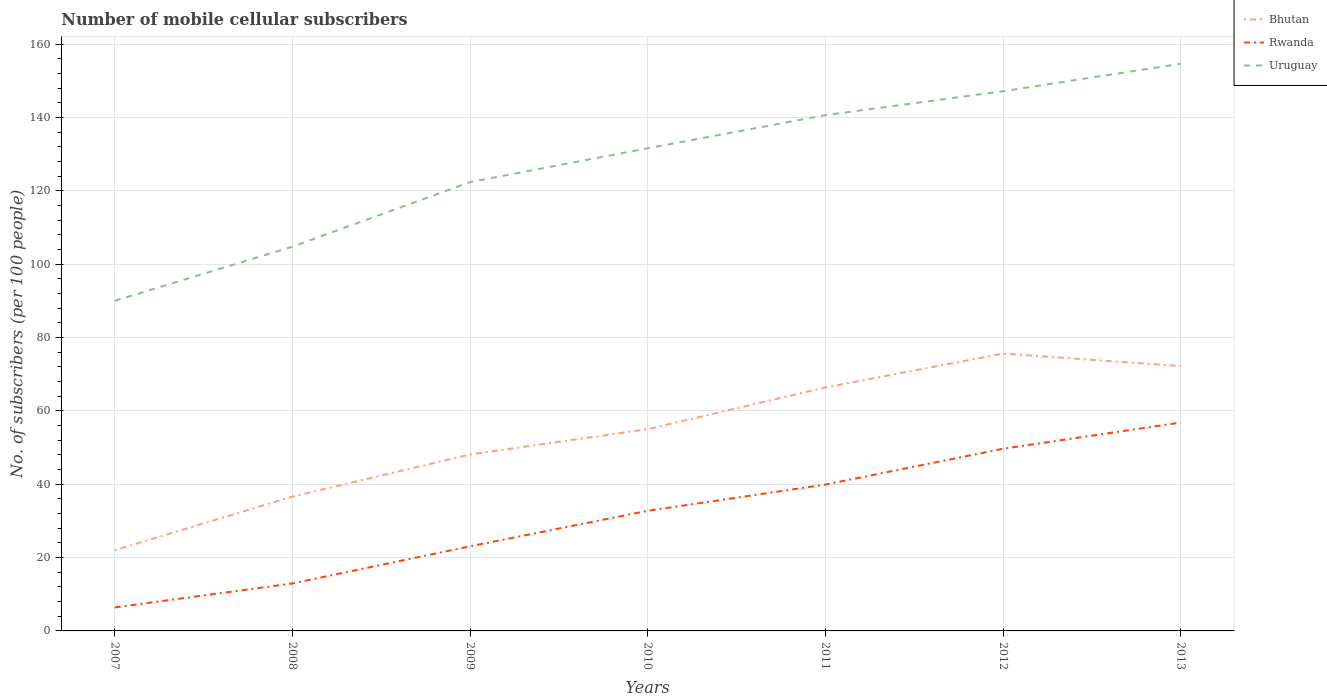Across all years, what is the maximum number of mobile cellular subscribers in Bhutan?
Keep it short and to the point. 22. In which year was the number of mobile cellular subscribers in Rwanda maximum?
Your answer should be very brief. 2007. What is the total number of mobile cellular subscribers in Rwanda in the graph?
Ensure brevity in your answer.  -7.13. What is the difference between the highest and the second highest number of mobile cellular subscribers in Rwanda?
Offer a terse response. 50.4. What is the difference between the highest and the lowest number of mobile cellular subscribers in Rwanda?
Make the answer very short. 4. Is the number of mobile cellular subscribers in Rwanda strictly greater than the number of mobile cellular subscribers in Bhutan over the years?
Offer a very short reply. Yes. How many lines are there?
Give a very brief answer. 3. Does the graph contain any zero values?
Keep it short and to the point. No. Does the graph contain grids?
Your answer should be very brief. Yes. What is the title of the graph?
Your response must be concise. Number of mobile cellular subscribers. What is the label or title of the Y-axis?
Your answer should be very brief. No. of subscribers (per 100 people). What is the No. of subscribers (per 100 people) of Bhutan in 2007?
Offer a very short reply. 22. What is the No. of subscribers (per 100 people) of Rwanda in 2007?
Provide a short and direct response. 6.4. What is the No. of subscribers (per 100 people) in Uruguay in 2007?
Keep it short and to the point. 89.99. What is the No. of subscribers (per 100 people) of Bhutan in 2008?
Provide a succinct answer. 36.61. What is the No. of subscribers (per 100 people) of Rwanda in 2008?
Provide a short and direct response. 12.94. What is the No. of subscribers (per 100 people) of Uruguay in 2008?
Your answer should be compact. 104.75. What is the No. of subscribers (per 100 people) of Bhutan in 2009?
Provide a succinct answer. 48.11. What is the No. of subscribers (per 100 people) of Rwanda in 2009?
Keep it short and to the point. 23.07. What is the No. of subscribers (per 100 people) in Uruguay in 2009?
Keep it short and to the point. 122.35. What is the No. of subscribers (per 100 people) in Bhutan in 2010?
Offer a very short reply. 55. What is the No. of subscribers (per 100 people) of Rwanda in 2010?
Ensure brevity in your answer.  32.75. What is the No. of subscribers (per 100 people) of Uruguay in 2010?
Your response must be concise. 131.59. What is the No. of subscribers (per 100 people) in Bhutan in 2011?
Ensure brevity in your answer.  66.38. What is the No. of subscribers (per 100 people) in Rwanda in 2011?
Your answer should be compact. 39.9. What is the No. of subscribers (per 100 people) in Uruguay in 2011?
Your answer should be very brief. 140.61. What is the No. of subscribers (per 100 people) in Bhutan in 2012?
Make the answer very short. 75.61. What is the No. of subscribers (per 100 people) of Rwanda in 2012?
Offer a terse response. 49.67. What is the No. of subscribers (per 100 people) in Uruguay in 2012?
Provide a short and direct response. 147.13. What is the No. of subscribers (per 100 people) of Bhutan in 2013?
Offer a terse response. 72.2. What is the No. of subscribers (per 100 people) of Rwanda in 2013?
Provide a short and direct response. 56.8. What is the No. of subscribers (per 100 people) of Uruguay in 2013?
Give a very brief answer. 154.62. Across all years, what is the maximum No. of subscribers (per 100 people) of Bhutan?
Provide a succinct answer. 75.61. Across all years, what is the maximum No. of subscribers (per 100 people) of Rwanda?
Offer a very short reply. 56.8. Across all years, what is the maximum No. of subscribers (per 100 people) in Uruguay?
Your answer should be compact. 154.62. Across all years, what is the minimum No. of subscribers (per 100 people) in Bhutan?
Keep it short and to the point. 22. Across all years, what is the minimum No. of subscribers (per 100 people) of Rwanda?
Offer a terse response. 6.4. Across all years, what is the minimum No. of subscribers (per 100 people) in Uruguay?
Ensure brevity in your answer.  89.99. What is the total No. of subscribers (per 100 people) of Bhutan in the graph?
Your answer should be compact. 375.91. What is the total No. of subscribers (per 100 people) of Rwanda in the graph?
Provide a short and direct response. 221.52. What is the total No. of subscribers (per 100 people) of Uruguay in the graph?
Your answer should be compact. 891.04. What is the difference between the No. of subscribers (per 100 people) in Bhutan in 2007 and that in 2008?
Ensure brevity in your answer.  -14.62. What is the difference between the No. of subscribers (per 100 people) in Rwanda in 2007 and that in 2008?
Your answer should be compact. -6.54. What is the difference between the No. of subscribers (per 100 people) of Uruguay in 2007 and that in 2008?
Offer a very short reply. -14.75. What is the difference between the No. of subscribers (per 100 people) in Bhutan in 2007 and that in 2009?
Your answer should be very brief. -26.11. What is the difference between the No. of subscribers (per 100 people) in Rwanda in 2007 and that in 2009?
Ensure brevity in your answer.  -16.67. What is the difference between the No. of subscribers (per 100 people) of Uruguay in 2007 and that in 2009?
Your answer should be compact. -32.36. What is the difference between the No. of subscribers (per 100 people) of Bhutan in 2007 and that in 2010?
Offer a terse response. -33. What is the difference between the No. of subscribers (per 100 people) in Rwanda in 2007 and that in 2010?
Offer a terse response. -26.35. What is the difference between the No. of subscribers (per 100 people) of Uruguay in 2007 and that in 2010?
Ensure brevity in your answer.  -41.6. What is the difference between the No. of subscribers (per 100 people) in Bhutan in 2007 and that in 2011?
Offer a terse response. -44.38. What is the difference between the No. of subscribers (per 100 people) of Rwanda in 2007 and that in 2011?
Your response must be concise. -33.5. What is the difference between the No. of subscribers (per 100 people) in Uruguay in 2007 and that in 2011?
Your answer should be very brief. -50.61. What is the difference between the No. of subscribers (per 100 people) in Bhutan in 2007 and that in 2012?
Keep it short and to the point. -53.61. What is the difference between the No. of subscribers (per 100 people) in Rwanda in 2007 and that in 2012?
Offer a terse response. -43.27. What is the difference between the No. of subscribers (per 100 people) of Uruguay in 2007 and that in 2012?
Give a very brief answer. -57.14. What is the difference between the No. of subscribers (per 100 people) in Bhutan in 2007 and that in 2013?
Your answer should be compact. -50.2. What is the difference between the No. of subscribers (per 100 people) of Rwanda in 2007 and that in 2013?
Give a very brief answer. -50.4. What is the difference between the No. of subscribers (per 100 people) of Uruguay in 2007 and that in 2013?
Give a very brief answer. -64.63. What is the difference between the No. of subscribers (per 100 people) of Bhutan in 2008 and that in 2009?
Offer a very short reply. -11.49. What is the difference between the No. of subscribers (per 100 people) in Rwanda in 2008 and that in 2009?
Your answer should be compact. -10.13. What is the difference between the No. of subscribers (per 100 people) of Uruguay in 2008 and that in 2009?
Provide a short and direct response. -17.61. What is the difference between the No. of subscribers (per 100 people) in Bhutan in 2008 and that in 2010?
Give a very brief answer. -18.39. What is the difference between the No. of subscribers (per 100 people) in Rwanda in 2008 and that in 2010?
Offer a very short reply. -19.81. What is the difference between the No. of subscribers (per 100 people) in Uruguay in 2008 and that in 2010?
Offer a very short reply. -26.84. What is the difference between the No. of subscribers (per 100 people) of Bhutan in 2008 and that in 2011?
Your response must be concise. -29.76. What is the difference between the No. of subscribers (per 100 people) of Rwanda in 2008 and that in 2011?
Your answer should be compact. -26.96. What is the difference between the No. of subscribers (per 100 people) of Uruguay in 2008 and that in 2011?
Provide a short and direct response. -35.86. What is the difference between the No. of subscribers (per 100 people) of Bhutan in 2008 and that in 2012?
Keep it short and to the point. -39. What is the difference between the No. of subscribers (per 100 people) of Rwanda in 2008 and that in 2012?
Offer a terse response. -36.73. What is the difference between the No. of subscribers (per 100 people) of Uruguay in 2008 and that in 2012?
Give a very brief answer. -42.39. What is the difference between the No. of subscribers (per 100 people) in Bhutan in 2008 and that in 2013?
Provide a short and direct response. -35.58. What is the difference between the No. of subscribers (per 100 people) of Rwanda in 2008 and that in 2013?
Offer a very short reply. -43.86. What is the difference between the No. of subscribers (per 100 people) in Uruguay in 2008 and that in 2013?
Provide a succinct answer. -49.87. What is the difference between the No. of subscribers (per 100 people) in Bhutan in 2009 and that in 2010?
Offer a very short reply. -6.89. What is the difference between the No. of subscribers (per 100 people) in Rwanda in 2009 and that in 2010?
Your answer should be compact. -9.68. What is the difference between the No. of subscribers (per 100 people) of Uruguay in 2009 and that in 2010?
Your answer should be compact. -9.24. What is the difference between the No. of subscribers (per 100 people) of Bhutan in 2009 and that in 2011?
Your answer should be very brief. -18.27. What is the difference between the No. of subscribers (per 100 people) in Rwanda in 2009 and that in 2011?
Provide a short and direct response. -16.83. What is the difference between the No. of subscribers (per 100 people) in Uruguay in 2009 and that in 2011?
Your response must be concise. -18.25. What is the difference between the No. of subscribers (per 100 people) in Bhutan in 2009 and that in 2012?
Provide a succinct answer. -27.5. What is the difference between the No. of subscribers (per 100 people) in Rwanda in 2009 and that in 2012?
Offer a very short reply. -26.6. What is the difference between the No. of subscribers (per 100 people) in Uruguay in 2009 and that in 2012?
Your answer should be very brief. -24.78. What is the difference between the No. of subscribers (per 100 people) of Bhutan in 2009 and that in 2013?
Ensure brevity in your answer.  -24.09. What is the difference between the No. of subscribers (per 100 people) of Rwanda in 2009 and that in 2013?
Give a very brief answer. -33.73. What is the difference between the No. of subscribers (per 100 people) in Uruguay in 2009 and that in 2013?
Give a very brief answer. -32.27. What is the difference between the No. of subscribers (per 100 people) in Bhutan in 2010 and that in 2011?
Offer a very short reply. -11.38. What is the difference between the No. of subscribers (per 100 people) of Rwanda in 2010 and that in 2011?
Ensure brevity in your answer.  -7.15. What is the difference between the No. of subscribers (per 100 people) in Uruguay in 2010 and that in 2011?
Offer a very short reply. -9.02. What is the difference between the No. of subscribers (per 100 people) of Bhutan in 2010 and that in 2012?
Provide a short and direct response. -20.61. What is the difference between the No. of subscribers (per 100 people) in Rwanda in 2010 and that in 2012?
Your response must be concise. -16.92. What is the difference between the No. of subscribers (per 100 people) in Uruguay in 2010 and that in 2012?
Your answer should be very brief. -15.54. What is the difference between the No. of subscribers (per 100 people) of Bhutan in 2010 and that in 2013?
Provide a short and direct response. -17.2. What is the difference between the No. of subscribers (per 100 people) in Rwanda in 2010 and that in 2013?
Ensure brevity in your answer.  -24.05. What is the difference between the No. of subscribers (per 100 people) of Uruguay in 2010 and that in 2013?
Keep it short and to the point. -23.03. What is the difference between the No. of subscribers (per 100 people) in Bhutan in 2011 and that in 2012?
Your answer should be compact. -9.23. What is the difference between the No. of subscribers (per 100 people) in Rwanda in 2011 and that in 2012?
Make the answer very short. -9.77. What is the difference between the No. of subscribers (per 100 people) of Uruguay in 2011 and that in 2012?
Give a very brief answer. -6.52. What is the difference between the No. of subscribers (per 100 people) of Bhutan in 2011 and that in 2013?
Offer a terse response. -5.82. What is the difference between the No. of subscribers (per 100 people) in Rwanda in 2011 and that in 2013?
Your answer should be compact. -16.9. What is the difference between the No. of subscribers (per 100 people) of Uruguay in 2011 and that in 2013?
Ensure brevity in your answer.  -14.01. What is the difference between the No. of subscribers (per 100 people) in Bhutan in 2012 and that in 2013?
Your response must be concise. 3.41. What is the difference between the No. of subscribers (per 100 people) of Rwanda in 2012 and that in 2013?
Keep it short and to the point. -7.13. What is the difference between the No. of subscribers (per 100 people) of Uruguay in 2012 and that in 2013?
Your response must be concise. -7.49. What is the difference between the No. of subscribers (per 100 people) in Bhutan in 2007 and the No. of subscribers (per 100 people) in Rwanda in 2008?
Provide a short and direct response. 9.06. What is the difference between the No. of subscribers (per 100 people) in Bhutan in 2007 and the No. of subscribers (per 100 people) in Uruguay in 2008?
Offer a very short reply. -82.75. What is the difference between the No. of subscribers (per 100 people) of Rwanda in 2007 and the No. of subscribers (per 100 people) of Uruguay in 2008?
Offer a very short reply. -98.35. What is the difference between the No. of subscribers (per 100 people) in Bhutan in 2007 and the No. of subscribers (per 100 people) in Rwanda in 2009?
Give a very brief answer. -1.07. What is the difference between the No. of subscribers (per 100 people) in Bhutan in 2007 and the No. of subscribers (per 100 people) in Uruguay in 2009?
Offer a very short reply. -100.36. What is the difference between the No. of subscribers (per 100 people) of Rwanda in 2007 and the No. of subscribers (per 100 people) of Uruguay in 2009?
Your response must be concise. -115.95. What is the difference between the No. of subscribers (per 100 people) of Bhutan in 2007 and the No. of subscribers (per 100 people) of Rwanda in 2010?
Offer a very short reply. -10.75. What is the difference between the No. of subscribers (per 100 people) of Bhutan in 2007 and the No. of subscribers (per 100 people) of Uruguay in 2010?
Offer a very short reply. -109.59. What is the difference between the No. of subscribers (per 100 people) of Rwanda in 2007 and the No. of subscribers (per 100 people) of Uruguay in 2010?
Keep it short and to the point. -125.19. What is the difference between the No. of subscribers (per 100 people) in Bhutan in 2007 and the No. of subscribers (per 100 people) in Rwanda in 2011?
Give a very brief answer. -17.9. What is the difference between the No. of subscribers (per 100 people) of Bhutan in 2007 and the No. of subscribers (per 100 people) of Uruguay in 2011?
Give a very brief answer. -118.61. What is the difference between the No. of subscribers (per 100 people) of Rwanda in 2007 and the No. of subscribers (per 100 people) of Uruguay in 2011?
Make the answer very short. -134.21. What is the difference between the No. of subscribers (per 100 people) of Bhutan in 2007 and the No. of subscribers (per 100 people) of Rwanda in 2012?
Offer a very short reply. -27.67. What is the difference between the No. of subscribers (per 100 people) in Bhutan in 2007 and the No. of subscribers (per 100 people) in Uruguay in 2012?
Keep it short and to the point. -125.13. What is the difference between the No. of subscribers (per 100 people) in Rwanda in 2007 and the No. of subscribers (per 100 people) in Uruguay in 2012?
Offer a terse response. -140.73. What is the difference between the No. of subscribers (per 100 people) in Bhutan in 2007 and the No. of subscribers (per 100 people) in Rwanda in 2013?
Provide a short and direct response. -34.8. What is the difference between the No. of subscribers (per 100 people) of Bhutan in 2007 and the No. of subscribers (per 100 people) of Uruguay in 2013?
Offer a terse response. -132.62. What is the difference between the No. of subscribers (per 100 people) of Rwanda in 2007 and the No. of subscribers (per 100 people) of Uruguay in 2013?
Provide a succinct answer. -148.22. What is the difference between the No. of subscribers (per 100 people) in Bhutan in 2008 and the No. of subscribers (per 100 people) in Rwanda in 2009?
Provide a short and direct response. 13.54. What is the difference between the No. of subscribers (per 100 people) of Bhutan in 2008 and the No. of subscribers (per 100 people) of Uruguay in 2009?
Make the answer very short. -85.74. What is the difference between the No. of subscribers (per 100 people) in Rwanda in 2008 and the No. of subscribers (per 100 people) in Uruguay in 2009?
Keep it short and to the point. -109.41. What is the difference between the No. of subscribers (per 100 people) in Bhutan in 2008 and the No. of subscribers (per 100 people) in Rwanda in 2010?
Give a very brief answer. 3.87. What is the difference between the No. of subscribers (per 100 people) of Bhutan in 2008 and the No. of subscribers (per 100 people) of Uruguay in 2010?
Your answer should be very brief. -94.97. What is the difference between the No. of subscribers (per 100 people) in Rwanda in 2008 and the No. of subscribers (per 100 people) in Uruguay in 2010?
Make the answer very short. -118.65. What is the difference between the No. of subscribers (per 100 people) of Bhutan in 2008 and the No. of subscribers (per 100 people) of Rwanda in 2011?
Give a very brief answer. -3.28. What is the difference between the No. of subscribers (per 100 people) in Bhutan in 2008 and the No. of subscribers (per 100 people) in Uruguay in 2011?
Provide a succinct answer. -103.99. What is the difference between the No. of subscribers (per 100 people) of Rwanda in 2008 and the No. of subscribers (per 100 people) of Uruguay in 2011?
Give a very brief answer. -127.67. What is the difference between the No. of subscribers (per 100 people) of Bhutan in 2008 and the No. of subscribers (per 100 people) of Rwanda in 2012?
Keep it short and to the point. -13.05. What is the difference between the No. of subscribers (per 100 people) of Bhutan in 2008 and the No. of subscribers (per 100 people) of Uruguay in 2012?
Provide a short and direct response. -110.52. What is the difference between the No. of subscribers (per 100 people) of Rwanda in 2008 and the No. of subscribers (per 100 people) of Uruguay in 2012?
Make the answer very short. -134.19. What is the difference between the No. of subscribers (per 100 people) of Bhutan in 2008 and the No. of subscribers (per 100 people) of Rwanda in 2013?
Your answer should be compact. -20.19. What is the difference between the No. of subscribers (per 100 people) in Bhutan in 2008 and the No. of subscribers (per 100 people) in Uruguay in 2013?
Your answer should be very brief. -118. What is the difference between the No. of subscribers (per 100 people) in Rwanda in 2008 and the No. of subscribers (per 100 people) in Uruguay in 2013?
Your answer should be compact. -141.68. What is the difference between the No. of subscribers (per 100 people) of Bhutan in 2009 and the No. of subscribers (per 100 people) of Rwanda in 2010?
Your answer should be compact. 15.36. What is the difference between the No. of subscribers (per 100 people) of Bhutan in 2009 and the No. of subscribers (per 100 people) of Uruguay in 2010?
Your answer should be very brief. -83.48. What is the difference between the No. of subscribers (per 100 people) of Rwanda in 2009 and the No. of subscribers (per 100 people) of Uruguay in 2010?
Your answer should be very brief. -108.52. What is the difference between the No. of subscribers (per 100 people) of Bhutan in 2009 and the No. of subscribers (per 100 people) of Rwanda in 2011?
Your response must be concise. 8.21. What is the difference between the No. of subscribers (per 100 people) of Bhutan in 2009 and the No. of subscribers (per 100 people) of Uruguay in 2011?
Your answer should be compact. -92.5. What is the difference between the No. of subscribers (per 100 people) of Rwanda in 2009 and the No. of subscribers (per 100 people) of Uruguay in 2011?
Ensure brevity in your answer.  -117.54. What is the difference between the No. of subscribers (per 100 people) in Bhutan in 2009 and the No. of subscribers (per 100 people) in Rwanda in 2012?
Your answer should be compact. -1.56. What is the difference between the No. of subscribers (per 100 people) in Bhutan in 2009 and the No. of subscribers (per 100 people) in Uruguay in 2012?
Give a very brief answer. -99.02. What is the difference between the No. of subscribers (per 100 people) in Rwanda in 2009 and the No. of subscribers (per 100 people) in Uruguay in 2012?
Offer a terse response. -124.06. What is the difference between the No. of subscribers (per 100 people) of Bhutan in 2009 and the No. of subscribers (per 100 people) of Rwanda in 2013?
Your answer should be very brief. -8.69. What is the difference between the No. of subscribers (per 100 people) in Bhutan in 2009 and the No. of subscribers (per 100 people) in Uruguay in 2013?
Provide a short and direct response. -106.51. What is the difference between the No. of subscribers (per 100 people) of Rwanda in 2009 and the No. of subscribers (per 100 people) of Uruguay in 2013?
Your answer should be compact. -131.55. What is the difference between the No. of subscribers (per 100 people) in Bhutan in 2010 and the No. of subscribers (per 100 people) in Rwanda in 2011?
Your response must be concise. 15.1. What is the difference between the No. of subscribers (per 100 people) in Bhutan in 2010 and the No. of subscribers (per 100 people) in Uruguay in 2011?
Offer a very short reply. -85.61. What is the difference between the No. of subscribers (per 100 people) in Rwanda in 2010 and the No. of subscribers (per 100 people) in Uruguay in 2011?
Keep it short and to the point. -107.86. What is the difference between the No. of subscribers (per 100 people) of Bhutan in 2010 and the No. of subscribers (per 100 people) of Rwanda in 2012?
Provide a succinct answer. 5.33. What is the difference between the No. of subscribers (per 100 people) in Bhutan in 2010 and the No. of subscribers (per 100 people) in Uruguay in 2012?
Your response must be concise. -92.13. What is the difference between the No. of subscribers (per 100 people) in Rwanda in 2010 and the No. of subscribers (per 100 people) in Uruguay in 2012?
Offer a terse response. -114.38. What is the difference between the No. of subscribers (per 100 people) in Bhutan in 2010 and the No. of subscribers (per 100 people) in Rwanda in 2013?
Offer a very short reply. -1.8. What is the difference between the No. of subscribers (per 100 people) of Bhutan in 2010 and the No. of subscribers (per 100 people) of Uruguay in 2013?
Provide a succinct answer. -99.62. What is the difference between the No. of subscribers (per 100 people) of Rwanda in 2010 and the No. of subscribers (per 100 people) of Uruguay in 2013?
Make the answer very short. -121.87. What is the difference between the No. of subscribers (per 100 people) of Bhutan in 2011 and the No. of subscribers (per 100 people) of Rwanda in 2012?
Ensure brevity in your answer.  16.71. What is the difference between the No. of subscribers (per 100 people) in Bhutan in 2011 and the No. of subscribers (per 100 people) in Uruguay in 2012?
Your answer should be very brief. -80.75. What is the difference between the No. of subscribers (per 100 people) of Rwanda in 2011 and the No. of subscribers (per 100 people) of Uruguay in 2012?
Offer a very short reply. -107.23. What is the difference between the No. of subscribers (per 100 people) in Bhutan in 2011 and the No. of subscribers (per 100 people) in Rwanda in 2013?
Your response must be concise. 9.58. What is the difference between the No. of subscribers (per 100 people) of Bhutan in 2011 and the No. of subscribers (per 100 people) of Uruguay in 2013?
Give a very brief answer. -88.24. What is the difference between the No. of subscribers (per 100 people) in Rwanda in 2011 and the No. of subscribers (per 100 people) in Uruguay in 2013?
Provide a short and direct response. -114.72. What is the difference between the No. of subscribers (per 100 people) in Bhutan in 2012 and the No. of subscribers (per 100 people) in Rwanda in 2013?
Provide a succinct answer. 18.81. What is the difference between the No. of subscribers (per 100 people) of Bhutan in 2012 and the No. of subscribers (per 100 people) of Uruguay in 2013?
Your response must be concise. -79.01. What is the difference between the No. of subscribers (per 100 people) in Rwanda in 2012 and the No. of subscribers (per 100 people) in Uruguay in 2013?
Provide a succinct answer. -104.95. What is the average No. of subscribers (per 100 people) in Bhutan per year?
Offer a terse response. 53.7. What is the average No. of subscribers (per 100 people) in Rwanda per year?
Ensure brevity in your answer.  31.65. What is the average No. of subscribers (per 100 people) of Uruguay per year?
Ensure brevity in your answer.  127.29. In the year 2007, what is the difference between the No. of subscribers (per 100 people) of Bhutan and No. of subscribers (per 100 people) of Rwanda?
Give a very brief answer. 15.6. In the year 2007, what is the difference between the No. of subscribers (per 100 people) in Bhutan and No. of subscribers (per 100 people) in Uruguay?
Offer a very short reply. -68. In the year 2007, what is the difference between the No. of subscribers (per 100 people) of Rwanda and No. of subscribers (per 100 people) of Uruguay?
Your answer should be very brief. -83.6. In the year 2008, what is the difference between the No. of subscribers (per 100 people) in Bhutan and No. of subscribers (per 100 people) in Rwanda?
Your response must be concise. 23.68. In the year 2008, what is the difference between the No. of subscribers (per 100 people) of Bhutan and No. of subscribers (per 100 people) of Uruguay?
Provide a succinct answer. -68.13. In the year 2008, what is the difference between the No. of subscribers (per 100 people) in Rwanda and No. of subscribers (per 100 people) in Uruguay?
Provide a short and direct response. -91.81. In the year 2009, what is the difference between the No. of subscribers (per 100 people) in Bhutan and No. of subscribers (per 100 people) in Rwanda?
Provide a succinct answer. 25.04. In the year 2009, what is the difference between the No. of subscribers (per 100 people) in Bhutan and No. of subscribers (per 100 people) in Uruguay?
Provide a succinct answer. -74.24. In the year 2009, what is the difference between the No. of subscribers (per 100 people) of Rwanda and No. of subscribers (per 100 people) of Uruguay?
Give a very brief answer. -99.28. In the year 2010, what is the difference between the No. of subscribers (per 100 people) in Bhutan and No. of subscribers (per 100 people) in Rwanda?
Offer a very short reply. 22.25. In the year 2010, what is the difference between the No. of subscribers (per 100 people) of Bhutan and No. of subscribers (per 100 people) of Uruguay?
Make the answer very short. -76.59. In the year 2010, what is the difference between the No. of subscribers (per 100 people) of Rwanda and No. of subscribers (per 100 people) of Uruguay?
Offer a terse response. -98.84. In the year 2011, what is the difference between the No. of subscribers (per 100 people) of Bhutan and No. of subscribers (per 100 people) of Rwanda?
Offer a terse response. 26.48. In the year 2011, what is the difference between the No. of subscribers (per 100 people) in Bhutan and No. of subscribers (per 100 people) in Uruguay?
Your answer should be very brief. -74.23. In the year 2011, what is the difference between the No. of subscribers (per 100 people) of Rwanda and No. of subscribers (per 100 people) of Uruguay?
Ensure brevity in your answer.  -100.71. In the year 2012, what is the difference between the No. of subscribers (per 100 people) in Bhutan and No. of subscribers (per 100 people) in Rwanda?
Your answer should be very brief. 25.94. In the year 2012, what is the difference between the No. of subscribers (per 100 people) in Bhutan and No. of subscribers (per 100 people) in Uruguay?
Give a very brief answer. -71.52. In the year 2012, what is the difference between the No. of subscribers (per 100 people) of Rwanda and No. of subscribers (per 100 people) of Uruguay?
Provide a succinct answer. -97.46. In the year 2013, what is the difference between the No. of subscribers (per 100 people) in Bhutan and No. of subscribers (per 100 people) in Rwanda?
Offer a terse response. 15.4. In the year 2013, what is the difference between the No. of subscribers (per 100 people) of Bhutan and No. of subscribers (per 100 people) of Uruguay?
Ensure brevity in your answer.  -82.42. In the year 2013, what is the difference between the No. of subscribers (per 100 people) in Rwanda and No. of subscribers (per 100 people) in Uruguay?
Offer a very short reply. -97.82. What is the ratio of the No. of subscribers (per 100 people) of Bhutan in 2007 to that in 2008?
Give a very brief answer. 0.6. What is the ratio of the No. of subscribers (per 100 people) in Rwanda in 2007 to that in 2008?
Your answer should be very brief. 0.49. What is the ratio of the No. of subscribers (per 100 people) in Uruguay in 2007 to that in 2008?
Provide a short and direct response. 0.86. What is the ratio of the No. of subscribers (per 100 people) in Bhutan in 2007 to that in 2009?
Make the answer very short. 0.46. What is the ratio of the No. of subscribers (per 100 people) of Rwanda in 2007 to that in 2009?
Offer a terse response. 0.28. What is the ratio of the No. of subscribers (per 100 people) in Uruguay in 2007 to that in 2009?
Make the answer very short. 0.74. What is the ratio of the No. of subscribers (per 100 people) in Bhutan in 2007 to that in 2010?
Your answer should be compact. 0.4. What is the ratio of the No. of subscribers (per 100 people) in Rwanda in 2007 to that in 2010?
Provide a short and direct response. 0.2. What is the ratio of the No. of subscribers (per 100 people) in Uruguay in 2007 to that in 2010?
Provide a short and direct response. 0.68. What is the ratio of the No. of subscribers (per 100 people) in Bhutan in 2007 to that in 2011?
Ensure brevity in your answer.  0.33. What is the ratio of the No. of subscribers (per 100 people) in Rwanda in 2007 to that in 2011?
Provide a succinct answer. 0.16. What is the ratio of the No. of subscribers (per 100 people) of Uruguay in 2007 to that in 2011?
Make the answer very short. 0.64. What is the ratio of the No. of subscribers (per 100 people) of Bhutan in 2007 to that in 2012?
Provide a short and direct response. 0.29. What is the ratio of the No. of subscribers (per 100 people) of Rwanda in 2007 to that in 2012?
Offer a very short reply. 0.13. What is the ratio of the No. of subscribers (per 100 people) in Uruguay in 2007 to that in 2012?
Provide a short and direct response. 0.61. What is the ratio of the No. of subscribers (per 100 people) of Bhutan in 2007 to that in 2013?
Offer a very short reply. 0.3. What is the ratio of the No. of subscribers (per 100 people) in Rwanda in 2007 to that in 2013?
Make the answer very short. 0.11. What is the ratio of the No. of subscribers (per 100 people) in Uruguay in 2007 to that in 2013?
Provide a short and direct response. 0.58. What is the ratio of the No. of subscribers (per 100 people) in Bhutan in 2008 to that in 2009?
Make the answer very short. 0.76. What is the ratio of the No. of subscribers (per 100 people) in Rwanda in 2008 to that in 2009?
Provide a succinct answer. 0.56. What is the ratio of the No. of subscribers (per 100 people) in Uruguay in 2008 to that in 2009?
Your answer should be compact. 0.86. What is the ratio of the No. of subscribers (per 100 people) of Bhutan in 2008 to that in 2010?
Make the answer very short. 0.67. What is the ratio of the No. of subscribers (per 100 people) of Rwanda in 2008 to that in 2010?
Your answer should be very brief. 0.4. What is the ratio of the No. of subscribers (per 100 people) in Uruguay in 2008 to that in 2010?
Provide a succinct answer. 0.8. What is the ratio of the No. of subscribers (per 100 people) in Bhutan in 2008 to that in 2011?
Give a very brief answer. 0.55. What is the ratio of the No. of subscribers (per 100 people) in Rwanda in 2008 to that in 2011?
Make the answer very short. 0.32. What is the ratio of the No. of subscribers (per 100 people) in Uruguay in 2008 to that in 2011?
Offer a terse response. 0.74. What is the ratio of the No. of subscribers (per 100 people) of Bhutan in 2008 to that in 2012?
Your response must be concise. 0.48. What is the ratio of the No. of subscribers (per 100 people) in Rwanda in 2008 to that in 2012?
Provide a short and direct response. 0.26. What is the ratio of the No. of subscribers (per 100 people) of Uruguay in 2008 to that in 2012?
Make the answer very short. 0.71. What is the ratio of the No. of subscribers (per 100 people) of Bhutan in 2008 to that in 2013?
Your answer should be compact. 0.51. What is the ratio of the No. of subscribers (per 100 people) in Rwanda in 2008 to that in 2013?
Keep it short and to the point. 0.23. What is the ratio of the No. of subscribers (per 100 people) in Uruguay in 2008 to that in 2013?
Provide a succinct answer. 0.68. What is the ratio of the No. of subscribers (per 100 people) of Bhutan in 2009 to that in 2010?
Ensure brevity in your answer.  0.87. What is the ratio of the No. of subscribers (per 100 people) of Rwanda in 2009 to that in 2010?
Ensure brevity in your answer.  0.7. What is the ratio of the No. of subscribers (per 100 people) in Uruguay in 2009 to that in 2010?
Provide a succinct answer. 0.93. What is the ratio of the No. of subscribers (per 100 people) in Bhutan in 2009 to that in 2011?
Provide a succinct answer. 0.72. What is the ratio of the No. of subscribers (per 100 people) of Rwanda in 2009 to that in 2011?
Offer a terse response. 0.58. What is the ratio of the No. of subscribers (per 100 people) in Uruguay in 2009 to that in 2011?
Your answer should be compact. 0.87. What is the ratio of the No. of subscribers (per 100 people) in Bhutan in 2009 to that in 2012?
Your response must be concise. 0.64. What is the ratio of the No. of subscribers (per 100 people) in Rwanda in 2009 to that in 2012?
Provide a short and direct response. 0.46. What is the ratio of the No. of subscribers (per 100 people) in Uruguay in 2009 to that in 2012?
Your answer should be compact. 0.83. What is the ratio of the No. of subscribers (per 100 people) in Bhutan in 2009 to that in 2013?
Offer a very short reply. 0.67. What is the ratio of the No. of subscribers (per 100 people) in Rwanda in 2009 to that in 2013?
Provide a succinct answer. 0.41. What is the ratio of the No. of subscribers (per 100 people) in Uruguay in 2009 to that in 2013?
Your response must be concise. 0.79. What is the ratio of the No. of subscribers (per 100 people) in Bhutan in 2010 to that in 2011?
Your answer should be compact. 0.83. What is the ratio of the No. of subscribers (per 100 people) in Rwanda in 2010 to that in 2011?
Your answer should be very brief. 0.82. What is the ratio of the No. of subscribers (per 100 people) in Uruguay in 2010 to that in 2011?
Ensure brevity in your answer.  0.94. What is the ratio of the No. of subscribers (per 100 people) in Bhutan in 2010 to that in 2012?
Make the answer very short. 0.73. What is the ratio of the No. of subscribers (per 100 people) in Rwanda in 2010 to that in 2012?
Offer a terse response. 0.66. What is the ratio of the No. of subscribers (per 100 people) of Uruguay in 2010 to that in 2012?
Make the answer very short. 0.89. What is the ratio of the No. of subscribers (per 100 people) of Bhutan in 2010 to that in 2013?
Keep it short and to the point. 0.76. What is the ratio of the No. of subscribers (per 100 people) in Rwanda in 2010 to that in 2013?
Make the answer very short. 0.58. What is the ratio of the No. of subscribers (per 100 people) in Uruguay in 2010 to that in 2013?
Your answer should be compact. 0.85. What is the ratio of the No. of subscribers (per 100 people) in Bhutan in 2011 to that in 2012?
Ensure brevity in your answer.  0.88. What is the ratio of the No. of subscribers (per 100 people) in Rwanda in 2011 to that in 2012?
Your response must be concise. 0.8. What is the ratio of the No. of subscribers (per 100 people) in Uruguay in 2011 to that in 2012?
Offer a terse response. 0.96. What is the ratio of the No. of subscribers (per 100 people) in Bhutan in 2011 to that in 2013?
Offer a terse response. 0.92. What is the ratio of the No. of subscribers (per 100 people) of Rwanda in 2011 to that in 2013?
Make the answer very short. 0.7. What is the ratio of the No. of subscribers (per 100 people) of Uruguay in 2011 to that in 2013?
Ensure brevity in your answer.  0.91. What is the ratio of the No. of subscribers (per 100 people) in Bhutan in 2012 to that in 2013?
Offer a terse response. 1.05. What is the ratio of the No. of subscribers (per 100 people) in Rwanda in 2012 to that in 2013?
Provide a short and direct response. 0.87. What is the ratio of the No. of subscribers (per 100 people) of Uruguay in 2012 to that in 2013?
Ensure brevity in your answer.  0.95. What is the difference between the highest and the second highest No. of subscribers (per 100 people) in Bhutan?
Your answer should be very brief. 3.41. What is the difference between the highest and the second highest No. of subscribers (per 100 people) of Rwanda?
Provide a short and direct response. 7.13. What is the difference between the highest and the second highest No. of subscribers (per 100 people) of Uruguay?
Make the answer very short. 7.49. What is the difference between the highest and the lowest No. of subscribers (per 100 people) in Bhutan?
Make the answer very short. 53.61. What is the difference between the highest and the lowest No. of subscribers (per 100 people) of Rwanda?
Make the answer very short. 50.4. What is the difference between the highest and the lowest No. of subscribers (per 100 people) of Uruguay?
Offer a very short reply. 64.63. 